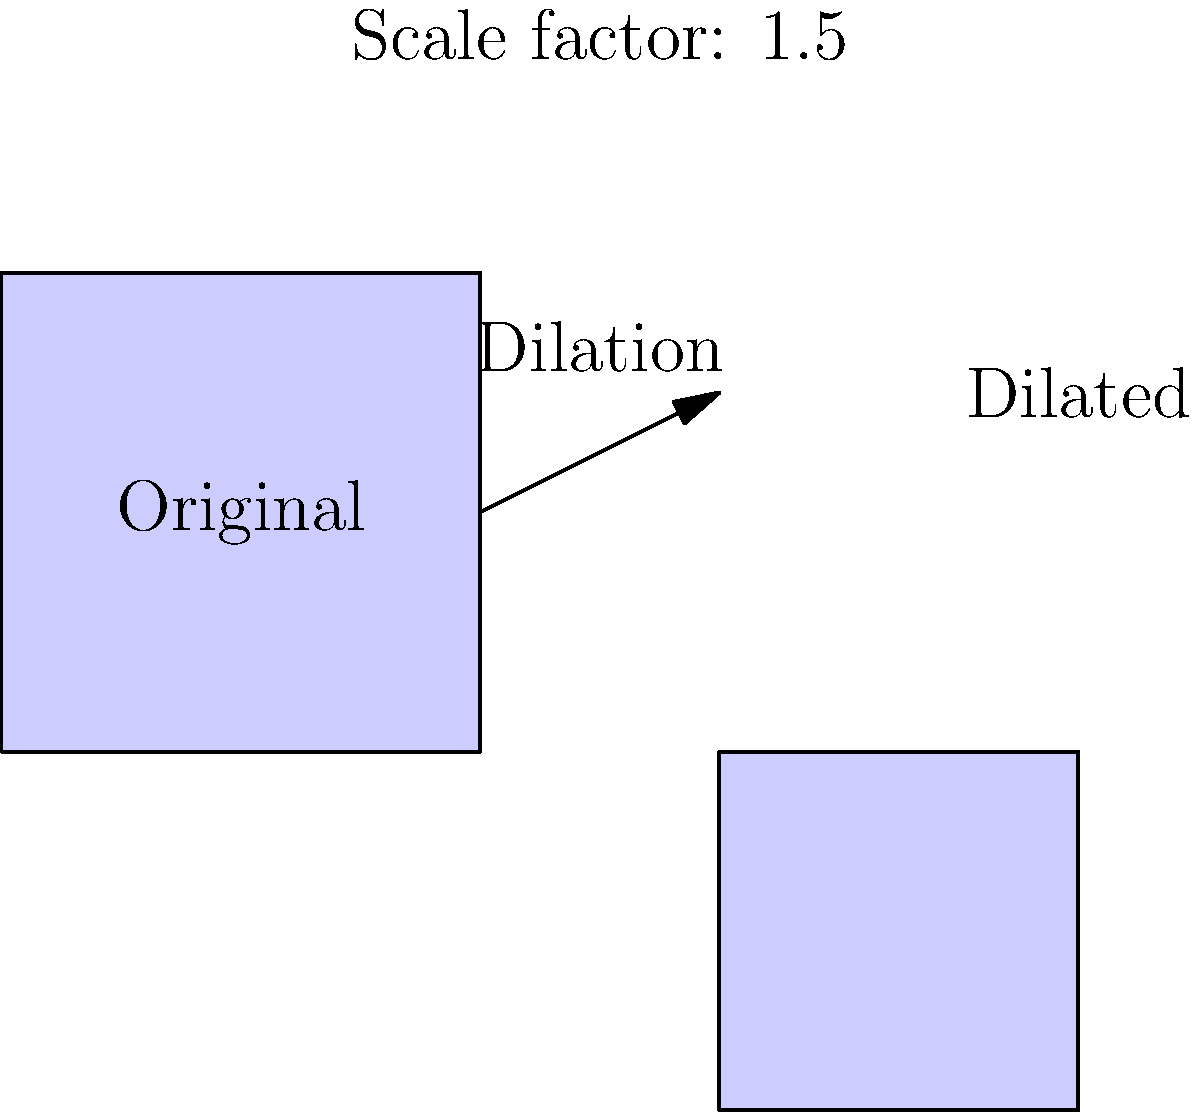Matthew Sweet's album cover artwork for "Girlfriend" needs to be resized for various concert merchandise. If the original artwork is 10 inches wide and you want to create a larger version for a concert poster using a scale factor of 1.5, what will be the width of the dilated image? To solve this problem, we need to understand the concept of dilation in transformational geometry. Dilation is a transformation that enlarges or shrinks a figure by a scale factor from a fixed point.

Step 1: Identify the given information
- Original width of the album cover: 10 inches
- Scale factor: 1.5

Step 2: Apply the dilation formula
The formula for dilation is:
$$ \text{New dimension} = \text{Original dimension} \times \text{Scale factor} $$

Step 3: Calculate the new width
$$ \text{New width} = 10 \text{ inches} \times 1.5 = 15 \text{ inches} $$

Therefore, the width of the dilated image for the concert poster will be 15 inches.
Answer: 15 inches 